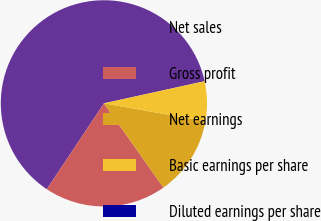Convert chart to OTSL. <chart><loc_0><loc_0><loc_500><loc_500><pie_chart><fcel>Net sales<fcel>Gross profit<fcel>Net earnings<fcel>Basic earnings per share<fcel>Diluted earnings per share<nl><fcel>62.21%<fcel>19.13%<fcel>12.44%<fcel>6.22%<fcel>0.0%<nl></chart> 